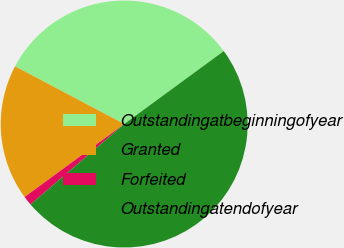<chart> <loc_0><loc_0><loc_500><loc_500><pie_chart><fcel>Outstandingatbeginningofyear<fcel>Granted<fcel>Forfeited<fcel>Outstandingatendofyear<nl><fcel>32.2%<fcel>17.8%<fcel>1.23%<fcel>48.77%<nl></chart> 